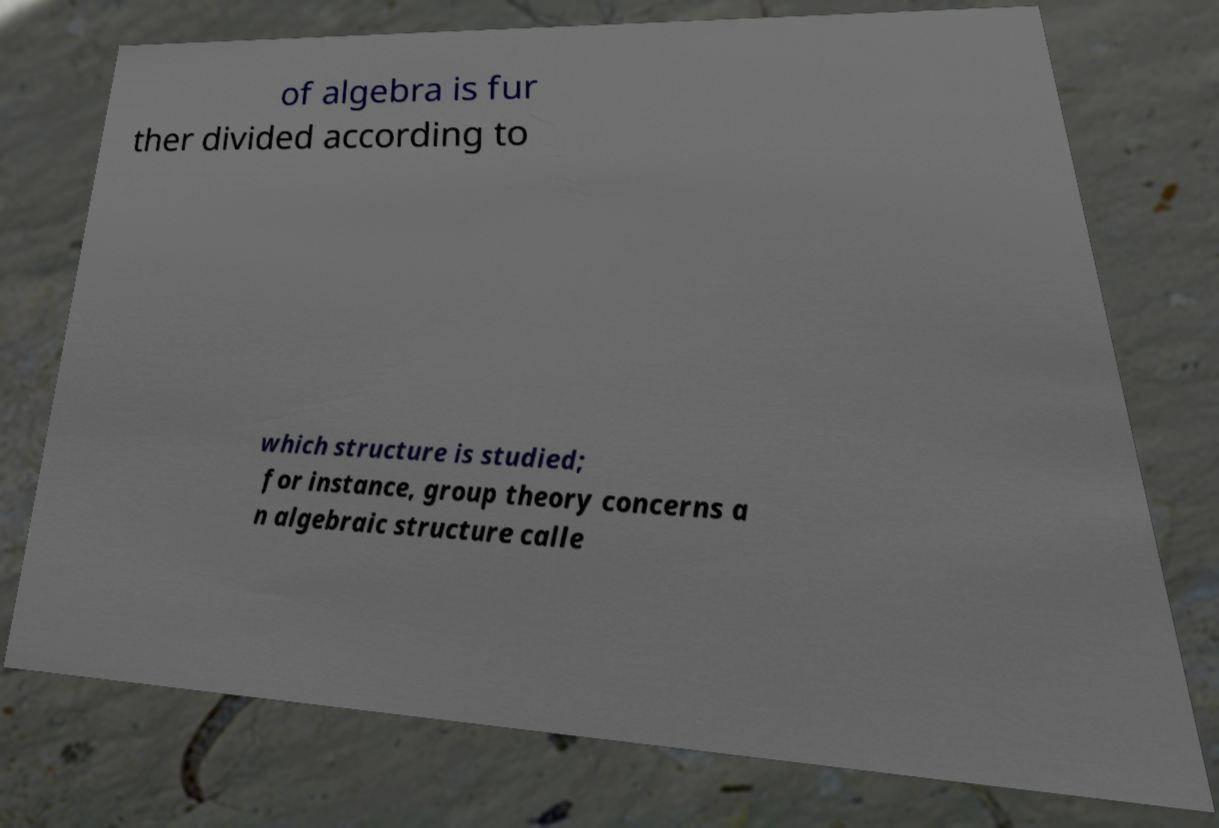Can you read and provide the text displayed in the image?This photo seems to have some interesting text. Can you extract and type it out for me? of algebra is fur ther divided according to which structure is studied; for instance, group theory concerns a n algebraic structure calle 